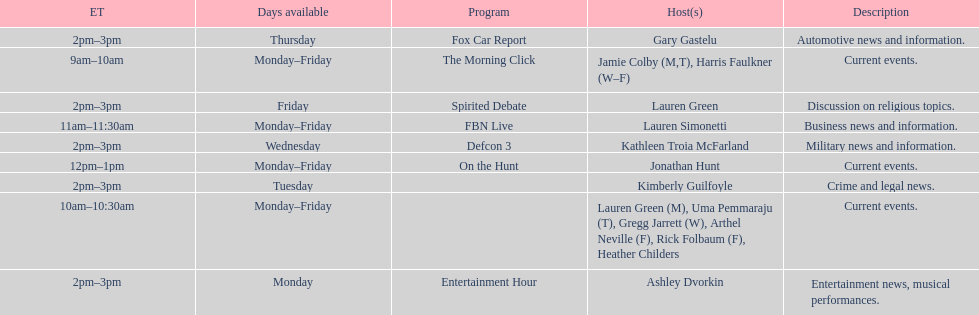What is the duration of on the hunt? 1 hour. 